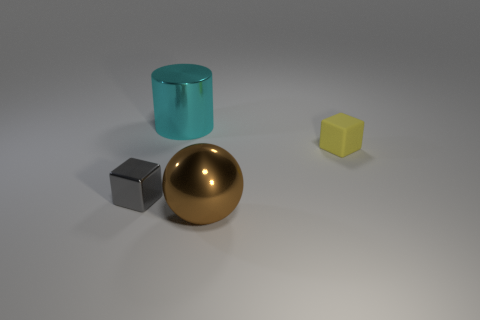What number of purple things are either small objects or big shiny balls?
Ensure brevity in your answer.  0. Do the cyan metallic object and the small object on the left side of the brown metallic sphere have the same shape?
Provide a short and direct response. No. There is a big cyan shiny object; what shape is it?
Provide a short and direct response. Cylinder. What is the material of the yellow cube that is the same size as the gray metal cube?
Give a very brief answer. Rubber. What number of objects are tiny purple matte cylinders or large objects that are behind the brown metal sphere?
Offer a terse response. 1. The cube that is the same material as the brown thing is what size?
Give a very brief answer. Small. The big object that is to the right of the metallic object behind the yellow block is what shape?
Provide a short and direct response. Sphere. There is a object that is behind the gray metal object and on the right side of the cylinder; what is its size?
Provide a short and direct response. Small. Is there another tiny thing of the same shape as the rubber thing?
Offer a terse response. Yes. Is there any other thing that has the same shape as the big brown metallic thing?
Ensure brevity in your answer.  No. 